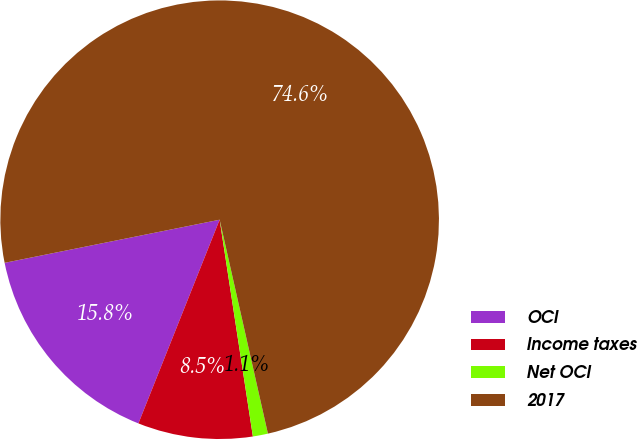<chart> <loc_0><loc_0><loc_500><loc_500><pie_chart><fcel>OCI<fcel>Income taxes<fcel>Net OCI<fcel>2017<nl><fcel>15.81%<fcel>8.46%<fcel>1.11%<fcel>74.61%<nl></chart> 